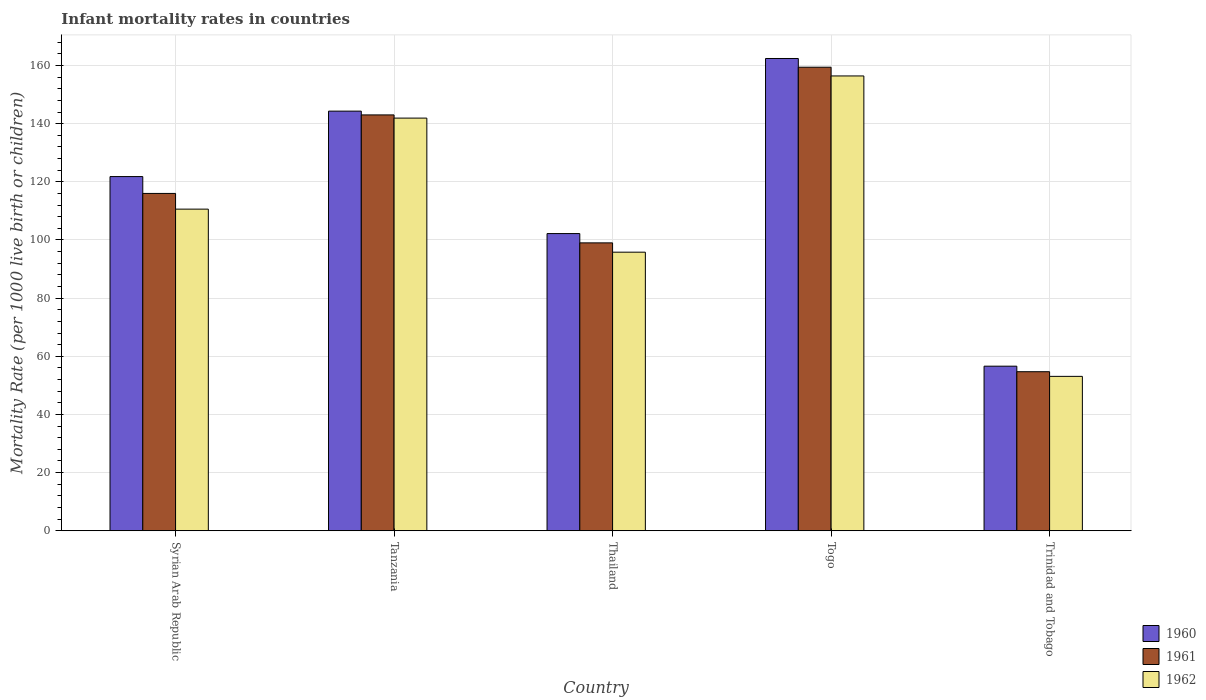How many groups of bars are there?
Give a very brief answer. 5. Are the number of bars per tick equal to the number of legend labels?
Offer a very short reply. Yes. Are the number of bars on each tick of the X-axis equal?
Offer a very short reply. Yes. How many bars are there on the 4th tick from the right?
Give a very brief answer. 3. What is the label of the 3rd group of bars from the left?
Provide a short and direct response. Thailand. In how many cases, is the number of bars for a given country not equal to the number of legend labels?
Keep it short and to the point. 0. What is the infant mortality rate in 1962 in Trinidad and Tobago?
Give a very brief answer. 53.1. Across all countries, what is the maximum infant mortality rate in 1961?
Your response must be concise. 159.4. Across all countries, what is the minimum infant mortality rate in 1961?
Provide a succinct answer. 54.7. In which country was the infant mortality rate in 1962 maximum?
Ensure brevity in your answer.  Togo. In which country was the infant mortality rate in 1962 minimum?
Offer a terse response. Trinidad and Tobago. What is the total infant mortality rate in 1962 in the graph?
Provide a succinct answer. 557.8. What is the difference between the infant mortality rate in 1960 in Tanzania and that in Trinidad and Tobago?
Your answer should be very brief. 87.7. What is the difference between the infant mortality rate in 1961 in Thailand and the infant mortality rate in 1960 in Tanzania?
Keep it short and to the point. -45.3. What is the average infant mortality rate in 1962 per country?
Your answer should be compact. 111.56. What is the difference between the infant mortality rate of/in 1960 and infant mortality rate of/in 1962 in Togo?
Give a very brief answer. 6. In how many countries, is the infant mortality rate in 1960 greater than 64?
Keep it short and to the point. 4. What is the ratio of the infant mortality rate in 1962 in Tanzania to that in Trinidad and Tobago?
Your response must be concise. 2.67. What is the difference between the highest and the second highest infant mortality rate in 1960?
Ensure brevity in your answer.  22.5. What is the difference between the highest and the lowest infant mortality rate in 1962?
Offer a terse response. 103.3. Are the values on the major ticks of Y-axis written in scientific E-notation?
Provide a succinct answer. No. Does the graph contain grids?
Your answer should be very brief. Yes. Where does the legend appear in the graph?
Provide a short and direct response. Bottom right. How are the legend labels stacked?
Your answer should be compact. Vertical. What is the title of the graph?
Your answer should be very brief. Infant mortality rates in countries. Does "1986" appear as one of the legend labels in the graph?
Offer a very short reply. No. What is the label or title of the Y-axis?
Offer a very short reply. Mortality Rate (per 1000 live birth or children). What is the Mortality Rate (per 1000 live birth or children) in 1960 in Syrian Arab Republic?
Ensure brevity in your answer.  121.8. What is the Mortality Rate (per 1000 live birth or children) in 1961 in Syrian Arab Republic?
Offer a very short reply. 116. What is the Mortality Rate (per 1000 live birth or children) of 1962 in Syrian Arab Republic?
Provide a short and direct response. 110.6. What is the Mortality Rate (per 1000 live birth or children) in 1960 in Tanzania?
Give a very brief answer. 144.3. What is the Mortality Rate (per 1000 live birth or children) in 1961 in Tanzania?
Make the answer very short. 143. What is the Mortality Rate (per 1000 live birth or children) in 1962 in Tanzania?
Provide a succinct answer. 141.9. What is the Mortality Rate (per 1000 live birth or children) of 1960 in Thailand?
Give a very brief answer. 102.2. What is the Mortality Rate (per 1000 live birth or children) in 1961 in Thailand?
Your answer should be compact. 99. What is the Mortality Rate (per 1000 live birth or children) in 1962 in Thailand?
Provide a short and direct response. 95.8. What is the Mortality Rate (per 1000 live birth or children) in 1960 in Togo?
Your answer should be compact. 162.4. What is the Mortality Rate (per 1000 live birth or children) of 1961 in Togo?
Provide a short and direct response. 159.4. What is the Mortality Rate (per 1000 live birth or children) of 1962 in Togo?
Provide a succinct answer. 156.4. What is the Mortality Rate (per 1000 live birth or children) of 1960 in Trinidad and Tobago?
Provide a short and direct response. 56.6. What is the Mortality Rate (per 1000 live birth or children) of 1961 in Trinidad and Tobago?
Ensure brevity in your answer.  54.7. What is the Mortality Rate (per 1000 live birth or children) in 1962 in Trinidad and Tobago?
Offer a very short reply. 53.1. Across all countries, what is the maximum Mortality Rate (per 1000 live birth or children) of 1960?
Give a very brief answer. 162.4. Across all countries, what is the maximum Mortality Rate (per 1000 live birth or children) in 1961?
Provide a short and direct response. 159.4. Across all countries, what is the maximum Mortality Rate (per 1000 live birth or children) of 1962?
Provide a short and direct response. 156.4. Across all countries, what is the minimum Mortality Rate (per 1000 live birth or children) of 1960?
Make the answer very short. 56.6. Across all countries, what is the minimum Mortality Rate (per 1000 live birth or children) of 1961?
Provide a short and direct response. 54.7. Across all countries, what is the minimum Mortality Rate (per 1000 live birth or children) in 1962?
Offer a terse response. 53.1. What is the total Mortality Rate (per 1000 live birth or children) in 1960 in the graph?
Give a very brief answer. 587.3. What is the total Mortality Rate (per 1000 live birth or children) in 1961 in the graph?
Offer a very short reply. 572.1. What is the total Mortality Rate (per 1000 live birth or children) of 1962 in the graph?
Provide a short and direct response. 557.8. What is the difference between the Mortality Rate (per 1000 live birth or children) of 1960 in Syrian Arab Republic and that in Tanzania?
Ensure brevity in your answer.  -22.5. What is the difference between the Mortality Rate (per 1000 live birth or children) in 1962 in Syrian Arab Republic and that in Tanzania?
Make the answer very short. -31.3. What is the difference between the Mortality Rate (per 1000 live birth or children) of 1960 in Syrian Arab Republic and that in Thailand?
Ensure brevity in your answer.  19.6. What is the difference between the Mortality Rate (per 1000 live birth or children) in 1961 in Syrian Arab Republic and that in Thailand?
Your answer should be compact. 17. What is the difference between the Mortality Rate (per 1000 live birth or children) of 1960 in Syrian Arab Republic and that in Togo?
Offer a very short reply. -40.6. What is the difference between the Mortality Rate (per 1000 live birth or children) of 1961 in Syrian Arab Republic and that in Togo?
Ensure brevity in your answer.  -43.4. What is the difference between the Mortality Rate (per 1000 live birth or children) in 1962 in Syrian Arab Republic and that in Togo?
Make the answer very short. -45.8. What is the difference between the Mortality Rate (per 1000 live birth or children) of 1960 in Syrian Arab Republic and that in Trinidad and Tobago?
Your response must be concise. 65.2. What is the difference between the Mortality Rate (per 1000 live birth or children) of 1961 in Syrian Arab Republic and that in Trinidad and Tobago?
Provide a short and direct response. 61.3. What is the difference between the Mortality Rate (per 1000 live birth or children) in 1962 in Syrian Arab Republic and that in Trinidad and Tobago?
Your answer should be compact. 57.5. What is the difference between the Mortality Rate (per 1000 live birth or children) of 1960 in Tanzania and that in Thailand?
Provide a succinct answer. 42.1. What is the difference between the Mortality Rate (per 1000 live birth or children) of 1961 in Tanzania and that in Thailand?
Your answer should be very brief. 44. What is the difference between the Mortality Rate (per 1000 live birth or children) in 1962 in Tanzania and that in Thailand?
Offer a terse response. 46.1. What is the difference between the Mortality Rate (per 1000 live birth or children) in 1960 in Tanzania and that in Togo?
Your response must be concise. -18.1. What is the difference between the Mortality Rate (per 1000 live birth or children) of 1961 in Tanzania and that in Togo?
Ensure brevity in your answer.  -16.4. What is the difference between the Mortality Rate (per 1000 live birth or children) in 1962 in Tanzania and that in Togo?
Your answer should be very brief. -14.5. What is the difference between the Mortality Rate (per 1000 live birth or children) of 1960 in Tanzania and that in Trinidad and Tobago?
Offer a terse response. 87.7. What is the difference between the Mortality Rate (per 1000 live birth or children) in 1961 in Tanzania and that in Trinidad and Tobago?
Ensure brevity in your answer.  88.3. What is the difference between the Mortality Rate (per 1000 live birth or children) of 1962 in Tanzania and that in Trinidad and Tobago?
Offer a terse response. 88.8. What is the difference between the Mortality Rate (per 1000 live birth or children) of 1960 in Thailand and that in Togo?
Provide a succinct answer. -60.2. What is the difference between the Mortality Rate (per 1000 live birth or children) in 1961 in Thailand and that in Togo?
Keep it short and to the point. -60.4. What is the difference between the Mortality Rate (per 1000 live birth or children) in 1962 in Thailand and that in Togo?
Provide a short and direct response. -60.6. What is the difference between the Mortality Rate (per 1000 live birth or children) of 1960 in Thailand and that in Trinidad and Tobago?
Your answer should be very brief. 45.6. What is the difference between the Mortality Rate (per 1000 live birth or children) in 1961 in Thailand and that in Trinidad and Tobago?
Ensure brevity in your answer.  44.3. What is the difference between the Mortality Rate (per 1000 live birth or children) of 1962 in Thailand and that in Trinidad and Tobago?
Your answer should be compact. 42.7. What is the difference between the Mortality Rate (per 1000 live birth or children) in 1960 in Togo and that in Trinidad and Tobago?
Provide a short and direct response. 105.8. What is the difference between the Mortality Rate (per 1000 live birth or children) in 1961 in Togo and that in Trinidad and Tobago?
Ensure brevity in your answer.  104.7. What is the difference between the Mortality Rate (per 1000 live birth or children) of 1962 in Togo and that in Trinidad and Tobago?
Make the answer very short. 103.3. What is the difference between the Mortality Rate (per 1000 live birth or children) in 1960 in Syrian Arab Republic and the Mortality Rate (per 1000 live birth or children) in 1961 in Tanzania?
Your answer should be very brief. -21.2. What is the difference between the Mortality Rate (per 1000 live birth or children) in 1960 in Syrian Arab Republic and the Mortality Rate (per 1000 live birth or children) in 1962 in Tanzania?
Provide a short and direct response. -20.1. What is the difference between the Mortality Rate (per 1000 live birth or children) in 1961 in Syrian Arab Republic and the Mortality Rate (per 1000 live birth or children) in 1962 in Tanzania?
Give a very brief answer. -25.9. What is the difference between the Mortality Rate (per 1000 live birth or children) in 1960 in Syrian Arab Republic and the Mortality Rate (per 1000 live birth or children) in 1961 in Thailand?
Keep it short and to the point. 22.8. What is the difference between the Mortality Rate (per 1000 live birth or children) in 1961 in Syrian Arab Republic and the Mortality Rate (per 1000 live birth or children) in 1962 in Thailand?
Your response must be concise. 20.2. What is the difference between the Mortality Rate (per 1000 live birth or children) of 1960 in Syrian Arab Republic and the Mortality Rate (per 1000 live birth or children) of 1961 in Togo?
Your response must be concise. -37.6. What is the difference between the Mortality Rate (per 1000 live birth or children) of 1960 in Syrian Arab Republic and the Mortality Rate (per 1000 live birth or children) of 1962 in Togo?
Your answer should be compact. -34.6. What is the difference between the Mortality Rate (per 1000 live birth or children) in 1961 in Syrian Arab Republic and the Mortality Rate (per 1000 live birth or children) in 1962 in Togo?
Provide a succinct answer. -40.4. What is the difference between the Mortality Rate (per 1000 live birth or children) of 1960 in Syrian Arab Republic and the Mortality Rate (per 1000 live birth or children) of 1961 in Trinidad and Tobago?
Make the answer very short. 67.1. What is the difference between the Mortality Rate (per 1000 live birth or children) of 1960 in Syrian Arab Republic and the Mortality Rate (per 1000 live birth or children) of 1962 in Trinidad and Tobago?
Provide a short and direct response. 68.7. What is the difference between the Mortality Rate (per 1000 live birth or children) of 1961 in Syrian Arab Republic and the Mortality Rate (per 1000 live birth or children) of 1962 in Trinidad and Tobago?
Give a very brief answer. 62.9. What is the difference between the Mortality Rate (per 1000 live birth or children) in 1960 in Tanzania and the Mortality Rate (per 1000 live birth or children) in 1961 in Thailand?
Provide a short and direct response. 45.3. What is the difference between the Mortality Rate (per 1000 live birth or children) in 1960 in Tanzania and the Mortality Rate (per 1000 live birth or children) in 1962 in Thailand?
Keep it short and to the point. 48.5. What is the difference between the Mortality Rate (per 1000 live birth or children) of 1961 in Tanzania and the Mortality Rate (per 1000 live birth or children) of 1962 in Thailand?
Offer a very short reply. 47.2. What is the difference between the Mortality Rate (per 1000 live birth or children) in 1960 in Tanzania and the Mortality Rate (per 1000 live birth or children) in 1961 in Togo?
Your answer should be compact. -15.1. What is the difference between the Mortality Rate (per 1000 live birth or children) of 1960 in Tanzania and the Mortality Rate (per 1000 live birth or children) of 1962 in Togo?
Your response must be concise. -12.1. What is the difference between the Mortality Rate (per 1000 live birth or children) in 1961 in Tanzania and the Mortality Rate (per 1000 live birth or children) in 1962 in Togo?
Provide a succinct answer. -13.4. What is the difference between the Mortality Rate (per 1000 live birth or children) of 1960 in Tanzania and the Mortality Rate (per 1000 live birth or children) of 1961 in Trinidad and Tobago?
Your response must be concise. 89.6. What is the difference between the Mortality Rate (per 1000 live birth or children) in 1960 in Tanzania and the Mortality Rate (per 1000 live birth or children) in 1962 in Trinidad and Tobago?
Provide a succinct answer. 91.2. What is the difference between the Mortality Rate (per 1000 live birth or children) in 1961 in Tanzania and the Mortality Rate (per 1000 live birth or children) in 1962 in Trinidad and Tobago?
Your response must be concise. 89.9. What is the difference between the Mortality Rate (per 1000 live birth or children) in 1960 in Thailand and the Mortality Rate (per 1000 live birth or children) in 1961 in Togo?
Ensure brevity in your answer.  -57.2. What is the difference between the Mortality Rate (per 1000 live birth or children) of 1960 in Thailand and the Mortality Rate (per 1000 live birth or children) of 1962 in Togo?
Provide a succinct answer. -54.2. What is the difference between the Mortality Rate (per 1000 live birth or children) of 1961 in Thailand and the Mortality Rate (per 1000 live birth or children) of 1962 in Togo?
Make the answer very short. -57.4. What is the difference between the Mortality Rate (per 1000 live birth or children) of 1960 in Thailand and the Mortality Rate (per 1000 live birth or children) of 1961 in Trinidad and Tobago?
Make the answer very short. 47.5. What is the difference between the Mortality Rate (per 1000 live birth or children) of 1960 in Thailand and the Mortality Rate (per 1000 live birth or children) of 1962 in Trinidad and Tobago?
Provide a short and direct response. 49.1. What is the difference between the Mortality Rate (per 1000 live birth or children) in 1961 in Thailand and the Mortality Rate (per 1000 live birth or children) in 1962 in Trinidad and Tobago?
Offer a very short reply. 45.9. What is the difference between the Mortality Rate (per 1000 live birth or children) in 1960 in Togo and the Mortality Rate (per 1000 live birth or children) in 1961 in Trinidad and Tobago?
Your response must be concise. 107.7. What is the difference between the Mortality Rate (per 1000 live birth or children) in 1960 in Togo and the Mortality Rate (per 1000 live birth or children) in 1962 in Trinidad and Tobago?
Give a very brief answer. 109.3. What is the difference between the Mortality Rate (per 1000 live birth or children) of 1961 in Togo and the Mortality Rate (per 1000 live birth or children) of 1962 in Trinidad and Tobago?
Give a very brief answer. 106.3. What is the average Mortality Rate (per 1000 live birth or children) of 1960 per country?
Your answer should be very brief. 117.46. What is the average Mortality Rate (per 1000 live birth or children) of 1961 per country?
Your answer should be very brief. 114.42. What is the average Mortality Rate (per 1000 live birth or children) in 1962 per country?
Ensure brevity in your answer.  111.56. What is the difference between the Mortality Rate (per 1000 live birth or children) of 1960 and Mortality Rate (per 1000 live birth or children) of 1961 in Syrian Arab Republic?
Your answer should be very brief. 5.8. What is the difference between the Mortality Rate (per 1000 live birth or children) of 1960 and Mortality Rate (per 1000 live birth or children) of 1962 in Syrian Arab Republic?
Your answer should be very brief. 11.2. What is the difference between the Mortality Rate (per 1000 live birth or children) of 1960 and Mortality Rate (per 1000 live birth or children) of 1961 in Tanzania?
Your answer should be very brief. 1.3. What is the difference between the Mortality Rate (per 1000 live birth or children) of 1960 and Mortality Rate (per 1000 live birth or children) of 1961 in Thailand?
Make the answer very short. 3.2. What is the difference between the Mortality Rate (per 1000 live birth or children) of 1960 and Mortality Rate (per 1000 live birth or children) of 1962 in Thailand?
Offer a terse response. 6.4. What is the difference between the Mortality Rate (per 1000 live birth or children) of 1961 and Mortality Rate (per 1000 live birth or children) of 1962 in Thailand?
Your answer should be compact. 3.2. What is the difference between the Mortality Rate (per 1000 live birth or children) in 1960 and Mortality Rate (per 1000 live birth or children) in 1961 in Togo?
Provide a succinct answer. 3. What is the difference between the Mortality Rate (per 1000 live birth or children) in 1961 and Mortality Rate (per 1000 live birth or children) in 1962 in Togo?
Give a very brief answer. 3. What is the difference between the Mortality Rate (per 1000 live birth or children) in 1960 and Mortality Rate (per 1000 live birth or children) in 1961 in Trinidad and Tobago?
Make the answer very short. 1.9. What is the difference between the Mortality Rate (per 1000 live birth or children) of 1960 and Mortality Rate (per 1000 live birth or children) of 1962 in Trinidad and Tobago?
Provide a short and direct response. 3.5. What is the difference between the Mortality Rate (per 1000 live birth or children) of 1961 and Mortality Rate (per 1000 live birth or children) of 1962 in Trinidad and Tobago?
Your answer should be very brief. 1.6. What is the ratio of the Mortality Rate (per 1000 live birth or children) in 1960 in Syrian Arab Republic to that in Tanzania?
Your answer should be very brief. 0.84. What is the ratio of the Mortality Rate (per 1000 live birth or children) of 1961 in Syrian Arab Republic to that in Tanzania?
Offer a very short reply. 0.81. What is the ratio of the Mortality Rate (per 1000 live birth or children) in 1962 in Syrian Arab Republic to that in Tanzania?
Provide a succinct answer. 0.78. What is the ratio of the Mortality Rate (per 1000 live birth or children) in 1960 in Syrian Arab Republic to that in Thailand?
Your response must be concise. 1.19. What is the ratio of the Mortality Rate (per 1000 live birth or children) of 1961 in Syrian Arab Republic to that in Thailand?
Provide a short and direct response. 1.17. What is the ratio of the Mortality Rate (per 1000 live birth or children) in 1962 in Syrian Arab Republic to that in Thailand?
Your answer should be very brief. 1.15. What is the ratio of the Mortality Rate (per 1000 live birth or children) in 1961 in Syrian Arab Republic to that in Togo?
Make the answer very short. 0.73. What is the ratio of the Mortality Rate (per 1000 live birth or children) of 1962 in Syrian Arab Republic to that in Togo?
Provide a short and direct response. 0.71. What is the ratio of the Mortality Rate (per 1000 live birth or children) of 1960 in Syrian Arab Republic to that in Trinidad and Tobago?
Provide a short and direct response. 2.15. What is the ratio of the Mortality Rate (per 1000 live birth or children) in 1961 in Syrian Arab Republic to that in Trinidad and Tobago?
Provide a short and direct response. 2.12. What is the ratio of the Mortality Rate (per 1000 live birth or children) of 1962 in Syrian Arab Republic to that in Trinidad and Tobago?
Your response must be concise. 2.08. What is the ratio of the Mortality Rate (per 1000 live birth or children) in 1960 in Tanzania to that in Thailand?
Provide a short and direct response. 1.41. What is the ratio of the Mortality Rate (per 1000 live birth or children) of 1961 in Tanzania to that in Thailand?
Make the answer very short. 1.44. What is the ratio of the Mortality Rate (per 1000 live birth or children) in 1962 in Tanzania to that in Thailand?
Ensure brevity in your answer.  1.48. What is the ratio of the Mortality Rate (per 1000 live birth or children) of 1960 in Tanzania to that in Togo?
Make the answer very short. 0.89. What is the ratio of the Mortality Rate (per 1000 live birth or children) in 1961 in Tanzania to that in Togo?
Offer a very short reply. 0.9. What is the ratio of the Mortality Rate (per 1000 live birth or children) in 1962 in Tanzania to that in Togo?
Offer a very short reply. 0.91. What is the ratio of the Mortality Rate (per 1000 live birth or children) in 1960 in Tanzania to that in Trinidad and Tobago?
Your answer should be very brief. 2.55. What is the ratio of the Mortality Rate (per 1000 live birth or children) of 1961 in Tanzania to that in Trinidad and Tobago?
Offer a very short reply. 2.61. What is the ratio of the Mortality Rate (per 1000 live birth or children) of 1962 in Tanzania to that in Trinidad and Tobago?
Give a very brief answer. 2.67. What is the ratio of the Mortality Rate (per 1000 live birth or children) in 1960 in Thailand to that in Togo?
Your response must be concise. 0.63. What is the ratio of the Mortality Rate (per 1000 live birth or children) in 1961 in Thailand to that in Togo?
Your response must be concise. 0.62. What is the ratio of the Mortality Rate (per 1000 live birth or children) of 1962 in Thailand to that in Togo?
Provide a succinct answer. 0.61. What is the ratio of the Mortality Rate (per 1000 live birth or children) of 1960 in Thailand to that in Trinidad and Tobago?
Offer a very short reply. 1.81. What is the ratio of the Mortality Rate (per 1000 live birth or children) in 1961 in Thailand to that in Trinidad and Tobago?
Give a very brief answer. 1.81. What is the ratio of the Mortality Rate (per 1000 live birth or children) in 1962 in Thailand to that in Trinidad and Tobago?
Your answer should be very brief. 1.8. What is the ratio of the Mortality Rate (per 1000 live birth or children) of 1960 in Togo to that in Trinidad and Tobago?
Give a very brief answer. 2.87. What is the ratio of the Mortality Rate (per 1000 live birth or children) of 1961 in Togo to that in Trinidad and Tobago?
Provide a short and direct response. 2.91. What is the ratio of the Mortality Rate (per 1000 live birth or children) in 1962 in Togo to that in Trinidad and Tobago?
Offer a terse response. 2.95. What is the difference between the highest and the second highest Mortality Rate (per 1000 live birth or children) of 1961?
Provide a short and direct response. 16.4. What is the difference between the highest and the second highest Mortality Rate (per 1000 live birth or children) of 1962?
Provide a short and direct response. 14.5. What is the difference between the highest and the lowest Mortality Rate (per 1000 live birth or children) of 1960?
Keep it short and to the point. 105.8. What is the difference between the highest and the lowest Mortality Rate (per 1000 live birth or children) in 1961?
Your answer should be compact. 104.7. What is the difference between the highest and the lowest Mortality Rate (per 1000 live birth or children) of 1962?
Offer a terse response. 103.3. 